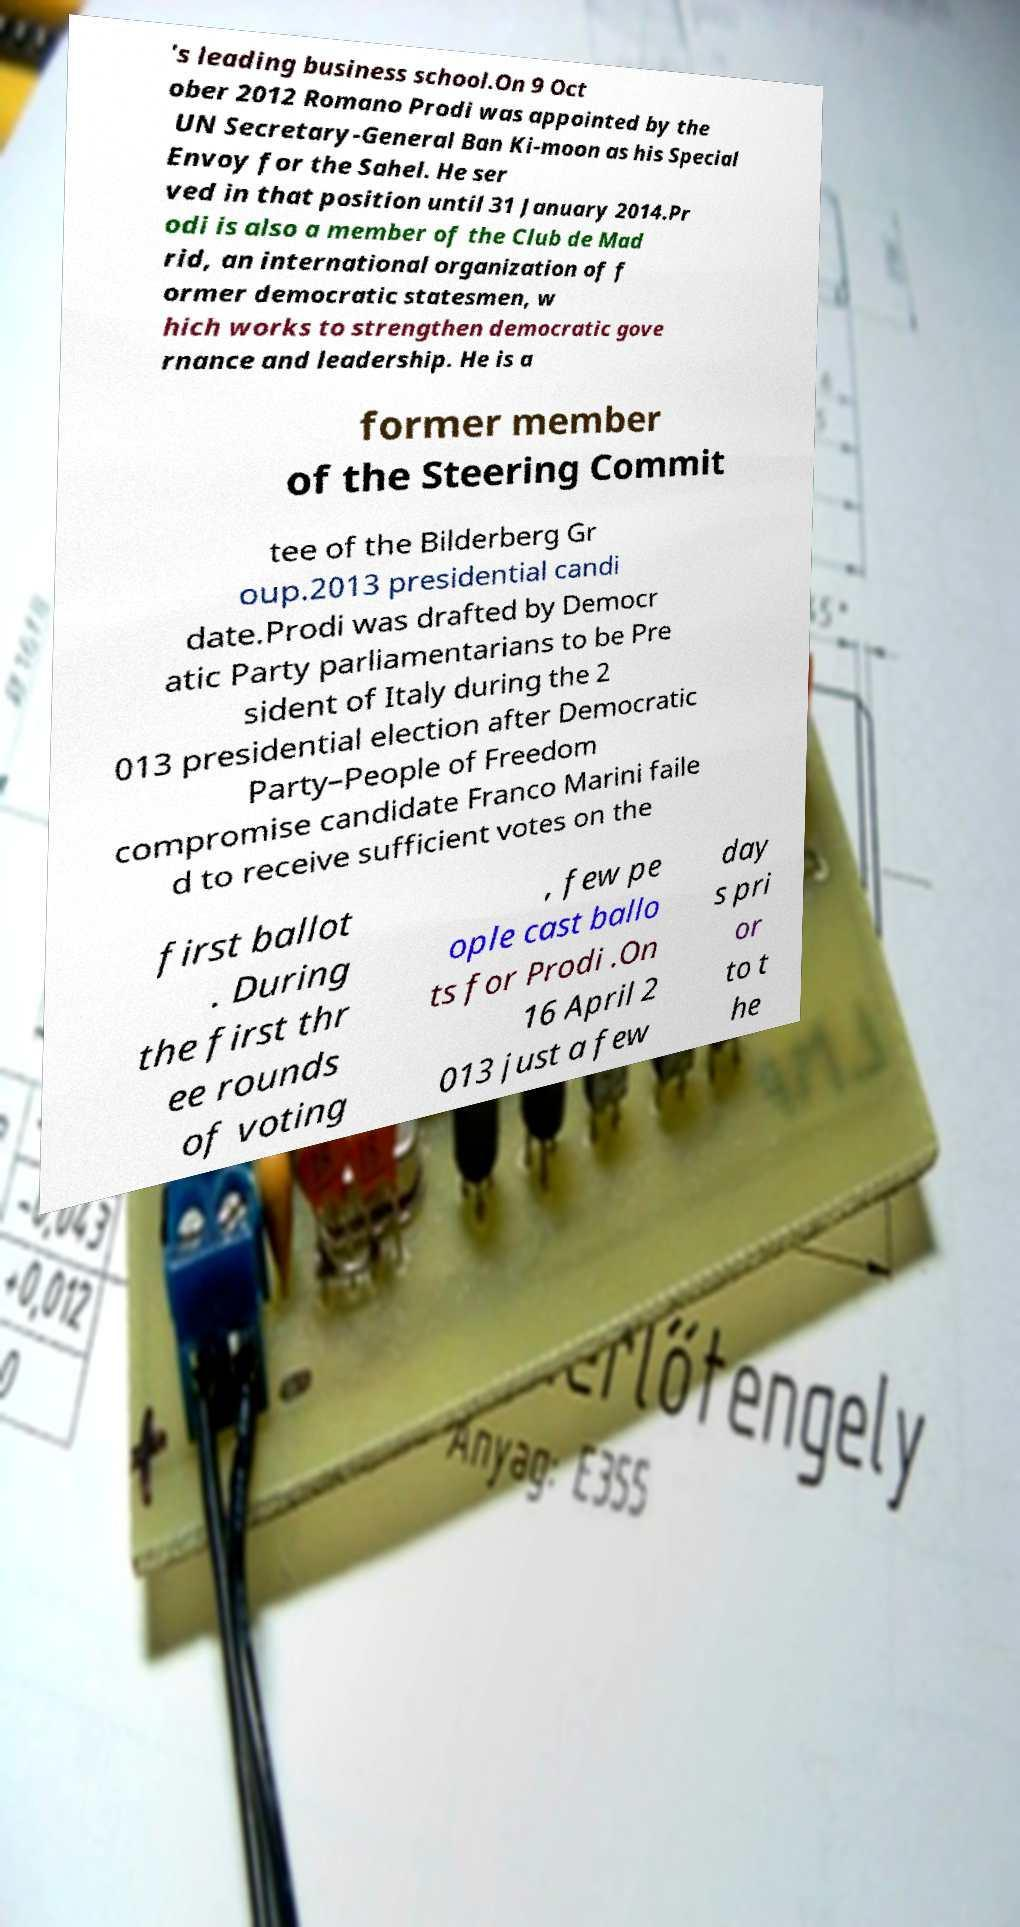What messages or text are displayed in this image? I need them in a readable, typed format. 's leading business school.On 9 Oct ober 2012 Romano Prodi was appointed by the UN Secretary-General Ban Ki-moon as his Special Envoy for the Sahel. He ser ved in that position until 31 January 2014.Pr odi is also a member of the Club de Mad rid, an international organization of f ormer democratic statesmen, w hich works to strengthen democratic gove rnance and leadership. He is a former member of the Steering Commit tee of the Bilderberg Gr oup.2013 presidential candi date.Prodi was drafted by Democr atic Party parliamentarians to be Pre sident of Italy during the 2 013 presidential election after Democratic Party–People of Freedom compromise candidate Franco Marini faile d to receive sufficient votes on the first ballot . During the first thr ee rounds of voting , few pe ople cast ballo ts for Prodi .On 16 April 2 013 just a few day s pri or to t he 